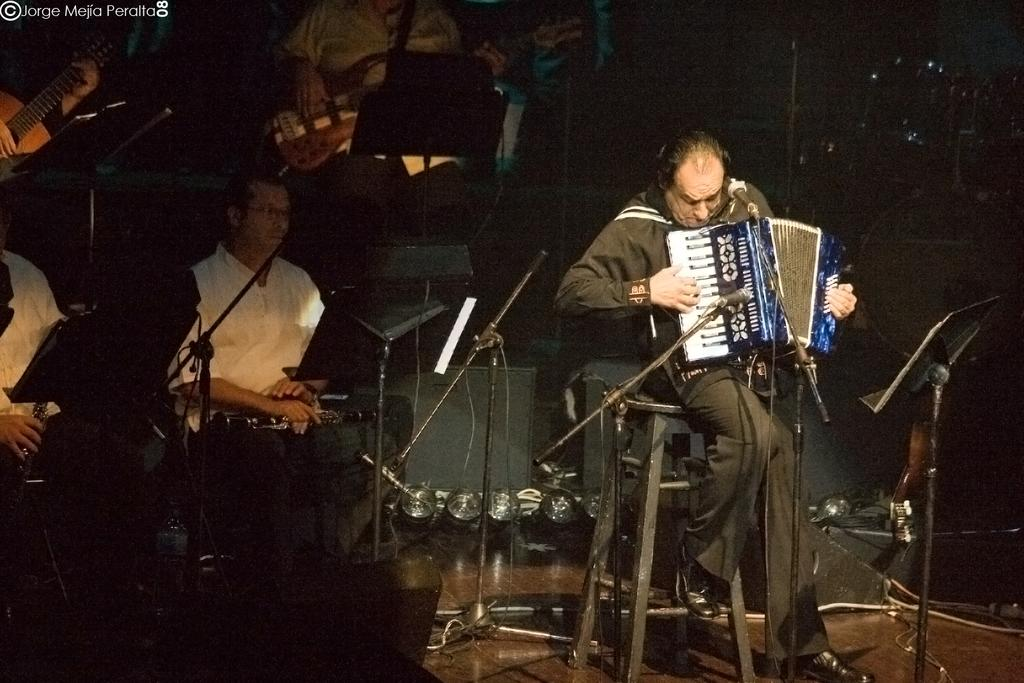What are the people in the image doing? The people in the image are holding musical instruments. What can be inferred about the activity taking place in the image? It appears to be a musical performance or practice, given that the people are holding musical instruments. Can you describe any additional features of the image? There is a watermark in the top left corner of the image. Where is the basin located in the image? There is no basin present in the image. What type of van can be seen in the background of the image? There is no van present in the image. 